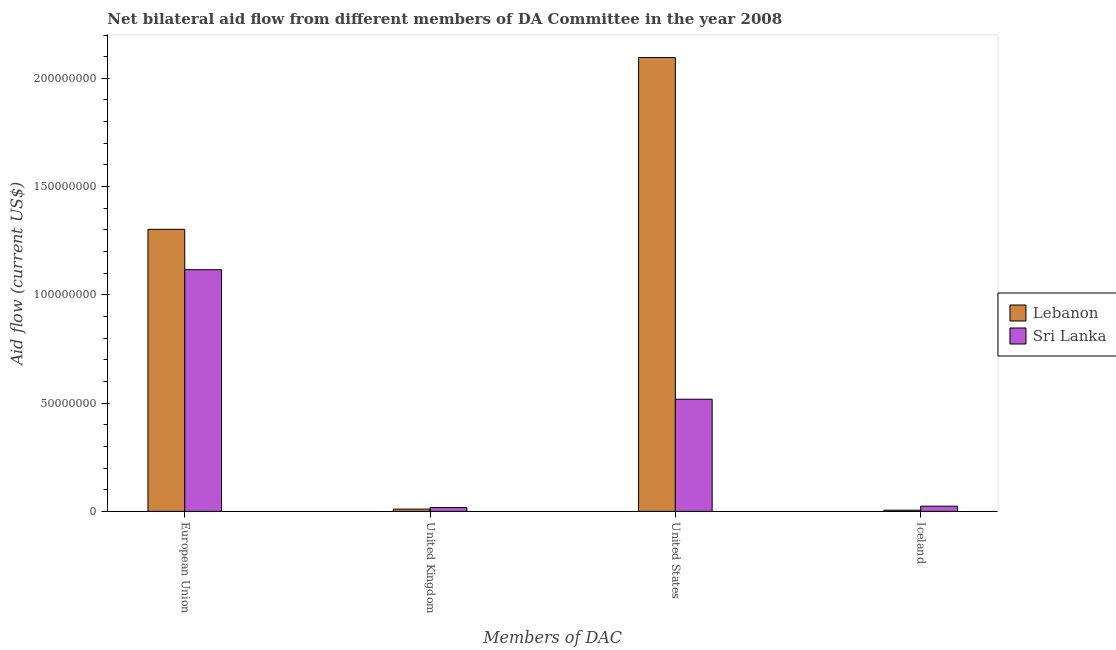How many different coloured bars are there?
Make the answer very short. 2. How many groups of bars are there?
Your answer should be very brief. 4. Are the number of bars per tick equal to the number of legend labels?
Your answer should be compact. Yes. Are the number of bars on each tick of the X-axis equal?
Your answer should be compact. Yes. How many bars are there on the 3rd tick from the left?
Provide a short and direct response. 2. How many bars are there on the 1st tick from the right?
Your answer should be compact. 2. What is the label of the 3rd group of bars from the left?
Ensure brevity in your answer.  United States. What is the amount of aid given by eu in Sri Lanka?
Ensure brevity in your answer.  1.12e+08. Across all countries, what is the maximum amount of aid given by iceland?
Keep it short and to the point. 2.39e+06. Across all countries, what is the minimum amount of aid given by uk?
Provide a succinct answer. 1.04e+06. In which country was the amount of aid given by eu maximum?
Provide a short and direct response. Lebanon. In which country was the amount of aid given by iceland minimum?
Your answer should be very brief. Lebanon. What is the total amount of aid given by uk in the graph?
Your answer should be compact. 2.79e+06. What is the difference between the amount of aid given by uk in Sri Lanka and that in Lebanon?
Your response must be concise. 7.10e+05. What is the difference between the amount of aid given by uk in Sri Lanka and the amount of aid given by eu in Lebanon?
Offer a very short reply. -1.28e+08. What is the average amount of aid given by iceland per country?
Make the answer very short. 1.47e+06. What is the difference between the amount of aid given by uk and amount of aid given by eu in Sri Lanka?
Provide a short and direct response. -1.10e+08. What is the ratio of the amount of aid given by uk in Lebanon to that in Sri Lanka?
Your answer should be very brief. 0.59. Is the difference between the amount of aid given by eu in Sri Lanka and Lebanon greater than the difference between the amount of aid given by iceland in Sri Lanka and Lebanon?
Provide a short and direct response. No. What is the difference between the highest and the second highest amount of aid given by eu?
Provide a succinct answer. 1.86e+07. What is the difference between the highest and the lowest amount of aid given by us?
Your response must be concise. 1.58e+08. What does the 1st bar from the left in European Union represents?
Provide a short and direct response. Lebanon. What does the 1st bar from the right in Iceland represents?
Provide a succinct answer. Sri Lanka. How many bars are there?
Provide a succinct answer. 8. Are all the bars in the graph horizontal?
Provide a succinct answer. No. Are the values on the major ticks of Y-axis written in scientific E-notation?
Offer a terse response. No. Does the graph contain any zero values?
Your answer should be very brief. No. Where does the legend appear in the graph?
Offer a very short reply. Center right. How many legend labels are there?
Offer a terse response. 2. How are the legend labels stacked?
Offer a very short reply. Vertical. What is the title of the graph?
Ensure brevity in your answer.  Net bilateral aid flow from different members of DA Committee in the year 2008. Does "Sub-Saharan Africa (developing only)" appear as one of the legend labels in the graph?
Your response must be concise. No. What is the label or title of the X-axis?
Your answer should be compact. Members of DAC. What is the Aid flow (current US$) of Lebanon in European Union?
Ensure brevity in your answer.  1.30e+08. What is the Aid flow (current US$) of Sri Lanka in European Union?
Keep it short and to the point. 1.12e+08. What is the Aid flow (current US$) in Lebanon in United Kingdom?
Ensure brevity in your answer.  1.04e+06. What is the Aid flow (current US$) in Sri Lanka in United Kingdom?
Your answer should be very brief. 1.75e+06. What is the Aid flow (current US$) of Lebanon in United States?
Provide a succinct answer. 2.10e+08. What is the Aid flow (current US$) in Sri Lanka in United States?
Your answer should be compact. 5.18e+07. What is the Aid flow (current US$) of Sri Lanka in Iceland?
Provide a succinct answer. 2.39e+06. Across all Members of DAC, what is the maximum Aid flow (current US$) of Lebanon?
Your answer should be compact. 2.10e+08. Across all Members of DAC, what is the maximum Aid flow (current US$) of Sri Lanka?
Provide a short and direct response. 1.12e+08. Across all Members of DAC, what is the minimum Aid flow (current US$) of Sri Lanka?
Keep it short and to the point. 1.75e+06. What is the total Aid flow (current US$) in Lebanon in the graph?
Keep it short and to the point. 3.41e+08. What is the total Aid flow (current US$) of Sri Lanka in the graph?
Give a very brief answer. 1.68e+08. What is the difference between the Aid flow (current US$) in Lebanon in European Union and that in United Kingdom?
Ensure brevity in your answer.  1.29e+08. What is the difference between the Aid flow (current US$) in Sri Lanka in European Union and that in United Kingdom?
Offer a very short reply. 1.10e+08. What is the difference between the Aid flow (current US$) of Lebanon in European Union and that in United States?
Give a very brief answer. -7.93e+07. What is the difference between the Aid flow (current US$) of Sri Lanka in European Union and that in United States?
Make the answer very short. 5.98e+07. What is the difference between the Aid flow (current US$) in Lebanon in European Union and that in Iceland?
Offer a very short reply. 1.30e+08. What is the difference between the Aid flow (current US$) in Sri Lanka in European Union and that in Iceland?
Your answer should be very brief. 1.09e+08. What is the difference between the Aid flow (current US$) of Lebanon in United Kingdom and that in United States?
Make the answer very short. -2.09e+08. What is the difference between the Aid flow (current US$) of Sri Lanka in United Kingdom and that in United States?
Provide a succinct answer. -5.00e+07. What is the difference between the Aid flow (current US$) in Sri Lanka in United Kingdom and that in Iceland?
Your answer should be compact. -6.40e+05. What is the difference between the Aid flow (current US$) in Lebanon in United States and that in Iceland?
Keep it short and to the point. 2.09e+08. What is the difference between the Aid flow (current US$) of Sri Lanka in United States and that in Iceland?
Your response must be concise. 4.94e+07. What is the difference between the Aid flow (current US$) of Lebanon in European Union and the Aid flow (current US$) of Sri Lanka in United Kingdom?
Ensure brevity in your answer.  1.28e+08. What is the difference between the Aid flow (current US$) in Lebanon in European Union and the Aid flow (current US$) in Sri Lanka in United States?
Give a very brief answer. 7.85e+07. What is the difference between the Aid flow (current US$) of Lebanon in European Union and the Aid flow (current US$) of Sri Lanka in Iceland?
Your answer should be compact. 1.28e+08. What is the difference between the Aid flow (current US$) of Lebanon in United Kingdom and the Aid flow (current US$) of Sri Lanka in United States?
Keep it short and to the point. -5.08e+07. What is the difference between the Aid flow (current US$) in Lebanon in United Kingdom and the Aid flow (current US$) in Sri Lanka in Iceland?
Offer a very short reply. -1.35e+06. What is the difference between the Aid flow (current US$) in Lebanon in United States and the Aid flow (current US$) in Sri Lanka in Iceland?
Make the answer very short. 2.07e+08. What is the average Aid flow (current US$) in Lebanon per Members of DAC?
Provide a succinct answer. 8.54e+07. What is the average Aid flow (current US$) in Sri Lanka per Members of DAC?
Offer a very short reply. 4.19e+07. What is the difference between the Aid flow (current US$) of Lebanon and Aid flow (current US$) of Sri Lanka in European Union?
Your answer should be very brief. 1.86e+07. What is the difference between the Aid flow (current US$) in Lebanon and Aid flow (current US$) in Sri Lanka in United Kingdom?
Offer a very short reply. -7.10e+05. What is the difference between the Aid flow (current US$) in Lebanon and Aid flow (current US$) in Sri Lanka in United States?
Your response must be concise. 1.58e+08. What is the difference between the Aid flow (current US$) in Lebanon and Aid flow (current US$) in Sri Lanka in Iceland?
Give a very brief answer. -1.84e+06. What is the ratio of the Aid flow (current US$) of Lebanon in European Union to that in United Kingdom?
Offer a very short reply. 125.24. What is the ratio of the Aid flow (current US$) in Sri Lanka in European Union to that in United Kingdom?
Offer a very short reply. 63.77. What is the ratio of the Aid flow (current US$) in Lebanon in European Union to that in United States?
Give a very brief answer. 0.62. What is the ratio of the Aid flow (current US$) of Sri Lanka in European Union to that in United States?
Ensure brevity in your answer.  2.15. What is the ratio of the Aid flow (current US$) of Lebanon in European Union to that in Iceland?
Your answer should be very brief. 236.82. What is the ratio of the Aid flow (current US$) of Sri Lanka in European Union to that in Iceland?
Provide a short and direct response. 46.69. What is the ratio of the Aid flow (current US$) in Lebanon in United Kingdom to that in United States?
Keep it short and to the point. 0.01. What is the ratio of the Aid flow (current US$) of Sri Lanka in United Kingdom to that in United States?
Your answer should be very brief. 0.03. What is the ratio of the Aid flow (current US$) in Lebanon in United Kingdom to that in Iceland?
Provide a succinct answer. 1.89. What is the ratio of the Aid flow (current US$) in Sri Lanka in United Kingdom to that in Iceland?
Offer a terse response. 0.73. What is the ratio of the Aid flow (current US$) of Lebanon in United States to that in Iceland?
Provide a succinct answer. 381.05. What is the ratio of the Aid flow (current US$) of Sri Lanka in United States to that in Iceland?
Your response must be concise. 21.67. What is the difference between the highest and the second highest Aid flow (current US$) in Lebanon?
Your response must be concise. 7.93e+07. What is the difference between the highest and the second highest Aid flow (current US$) of Sri Lanka?
Your answer should be compact. 5.98e+07. What is the difference between the highest and the lowest Aid flow (current US$) of Lebanon?
Your response must be concise. 2.09e+08. What is the difference between the highest and the lowest Aid flow (current US$) in Sri Lanka?
Offer a very short reply. 1.10e+08. 